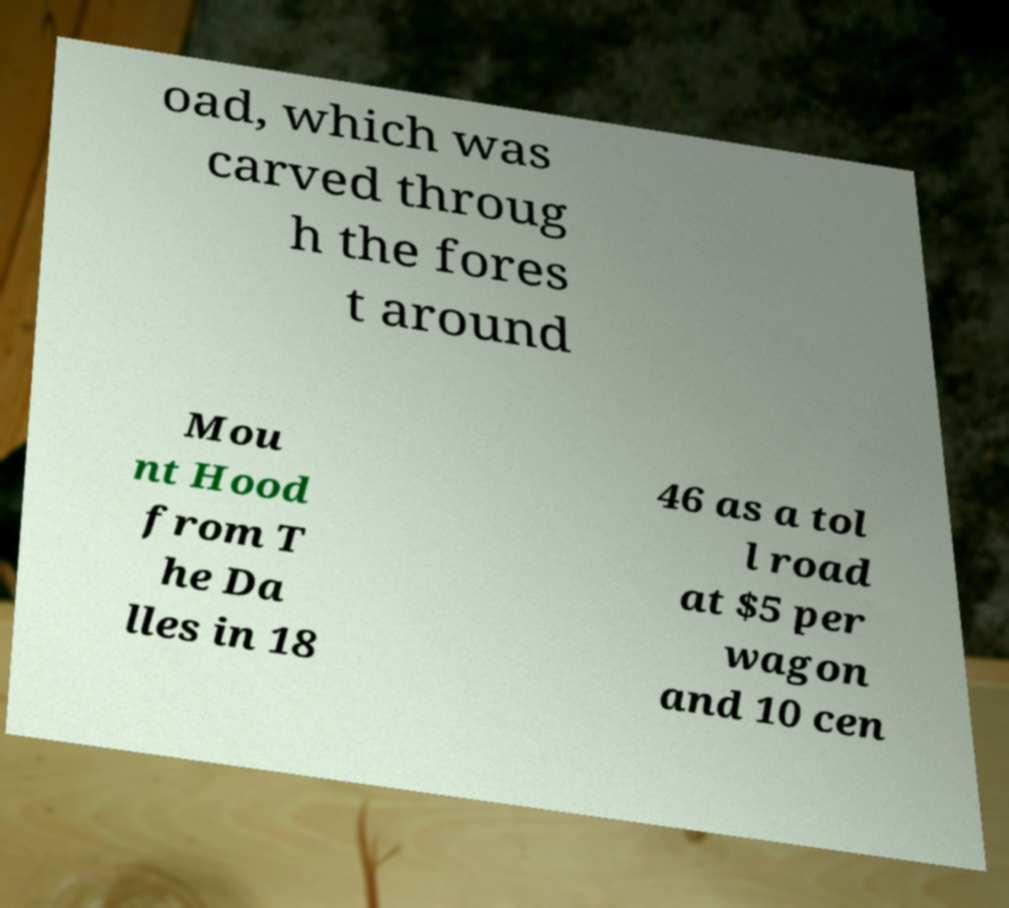For documentation purposes, I need the text within this image transcribed. Could you provide that? oad, which was carved throug h the fores t around Mou nt Hood from T he Da lles in 18 46 as a tol l road at $5 per wagon and 10 cen 